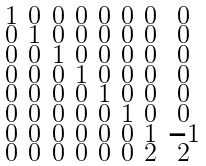Convert formula to latex. <formula><loc_0><loc_0><loc_500><loc_500>\begin{smallmatrix} 1 & 0 & 0 & 0 & 0 & 0 & 0 & 0 \\ 0 & 1 & 0 & 0 & 0 & 0 & 0 & 0 \\ 0 & 0 & 1 & 0 & 0 & 0 & 0 & 0 \\ 0 & 0 & 0 & 1 & 0 & 0 & 0 & 0 \\ 0 & 0 & 0 & 0 & 1 & 0 & 0 & 0 \\ 0 & 0 & 0 & 0 & 0 & 1 & 0 & 0 \\ 0 & 0 & 0 & 0 & 0 & 0 & 1 & - 1 \\ 0 & 0 & 0 & 0 & 0 & 0 & 2 & 2 \end{smallmatrix}</formula> 